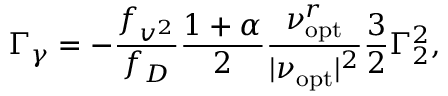<formula> <loc_0><loc_0><loc_500><loc_500>\Gamma _ { \gamma } = - \frac { f _ { v ^ { 2 } } } { f _ { D } } \frac { 1 + \alpha } { 2 } \frac { \nu _ { o p t } ^ { r } } { | \nu _ { o p t } | ^ { 2 } } \frac { 3 } { 2 } \Gamma _ { 2 } ^ { 2 } ,</formula> 